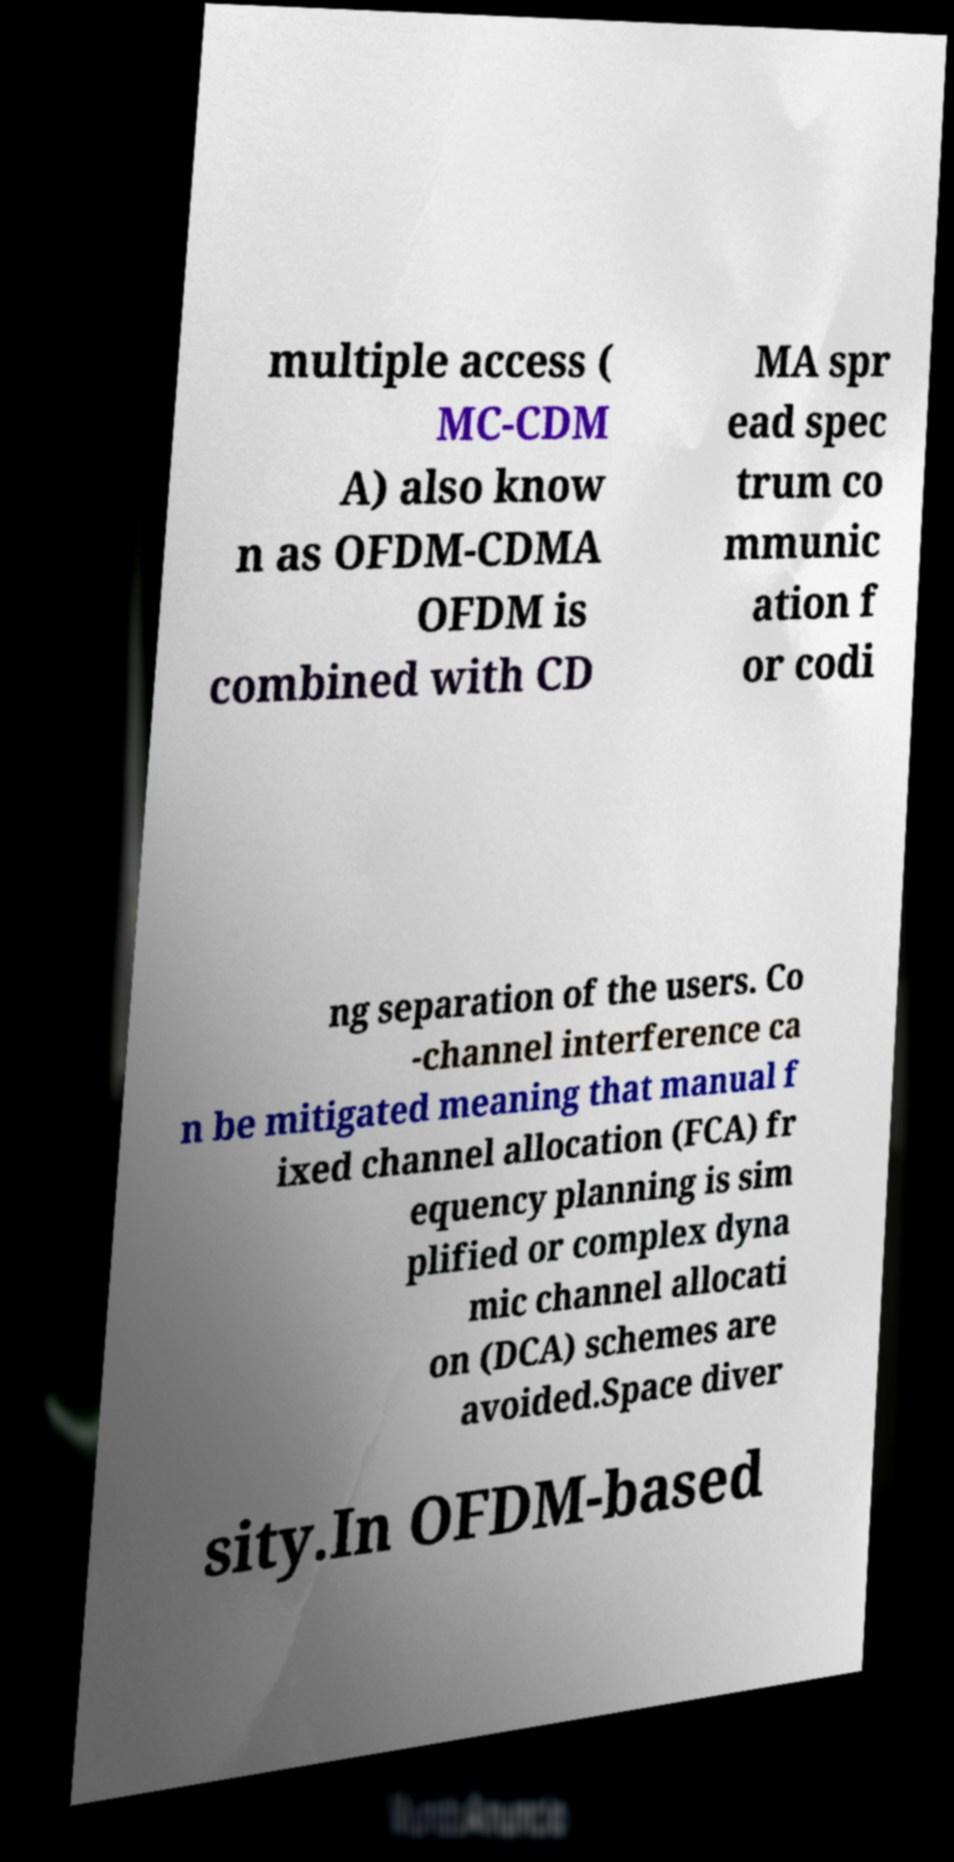Can you accurately transcribe the text from the provided image for me? multiple access ( MC-CDM A) also know n as OFDM-CDMA OFDM is combined with CD MA spr ead spec trum co mmunic ation f or codi ng separation of the users. Co -channel interference ca n be mitigated meaning that manual f ixed channel allocation (FCA) fr equency planning is sim plified or complex dyna mic channel allocati on (DCA) schemes are avoided.Space diver sity.In OFDM-based 